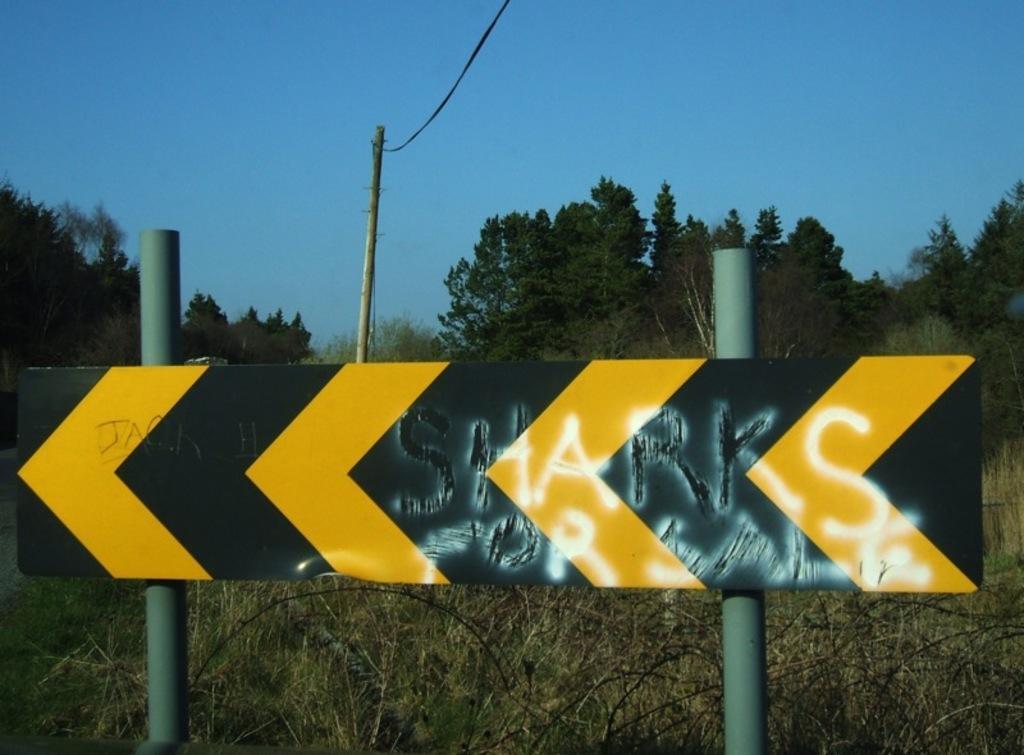Describe this image in one or two sentences. In this picture I can see the text on the board, in the background there are trees. At the top there is the sky. 